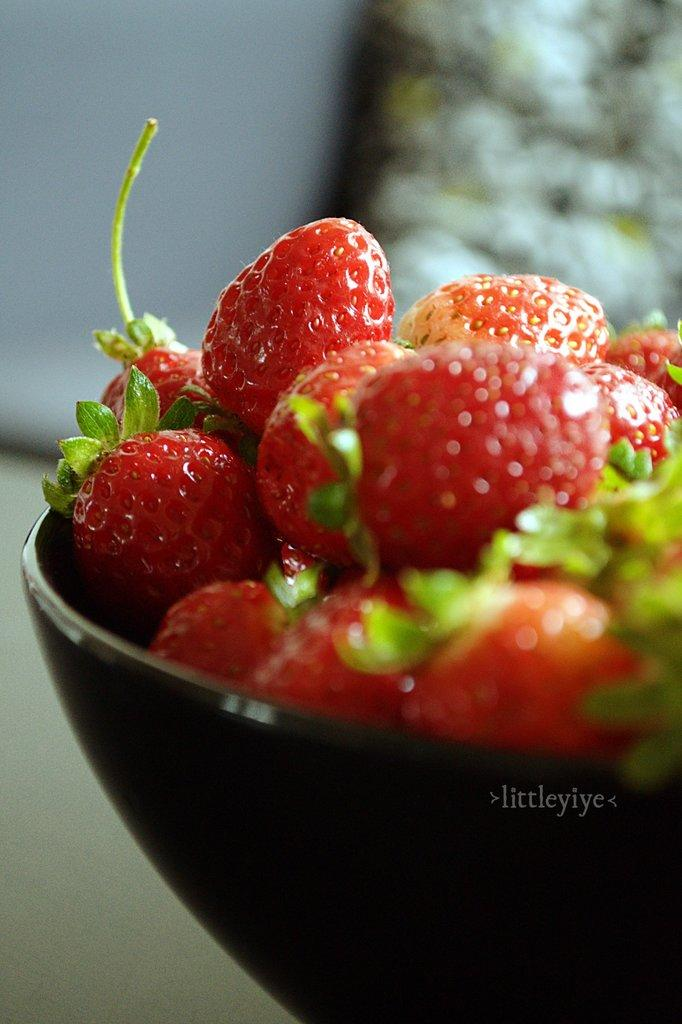What is the main piece of furniture in the image? There is a table in the image. What is placed on the table? There is a bowl on the table. What is inside the bowl? The bowl contains strawberries. What color is the background of the image? The background of the image appears to be white. How many balls are present on the table in the image? There are no balls present on the table in the image. What type of committee is meeting in the image? There is no committee meeting in the image; it features a table with a bowl of strawberries. 